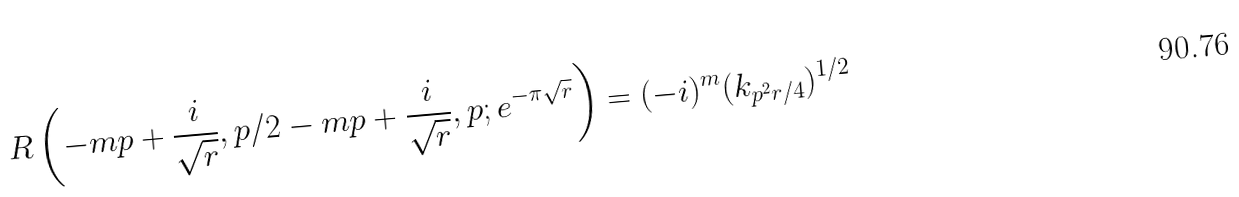Convert formula to latex. <formula><loc_0><loc_0><loc_500><loc_500>R \left ( - m p + \frac { i } { \sqrt { r } } , p / 2 - m p + \frac { i } { \sqrt { r } } , p ; e ^ { - \pi \sqrt { r } } \right ) = ( - i ) ^ { m } ( k _ { p ^ { 2 } r / 4 } ) ^ { 1 / 2 }</formula> 